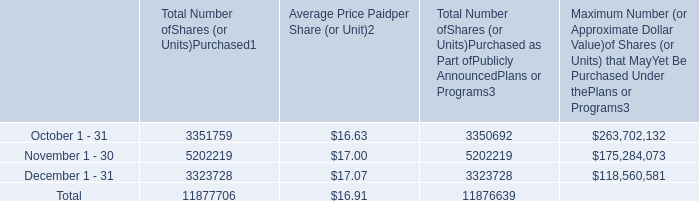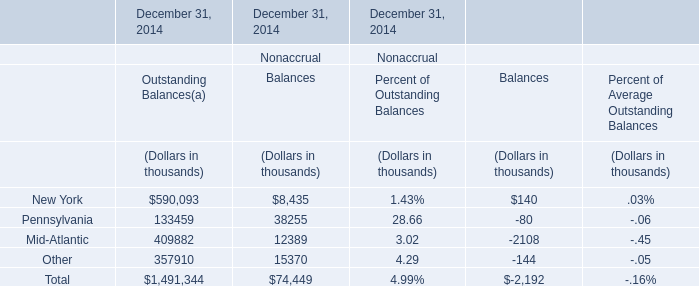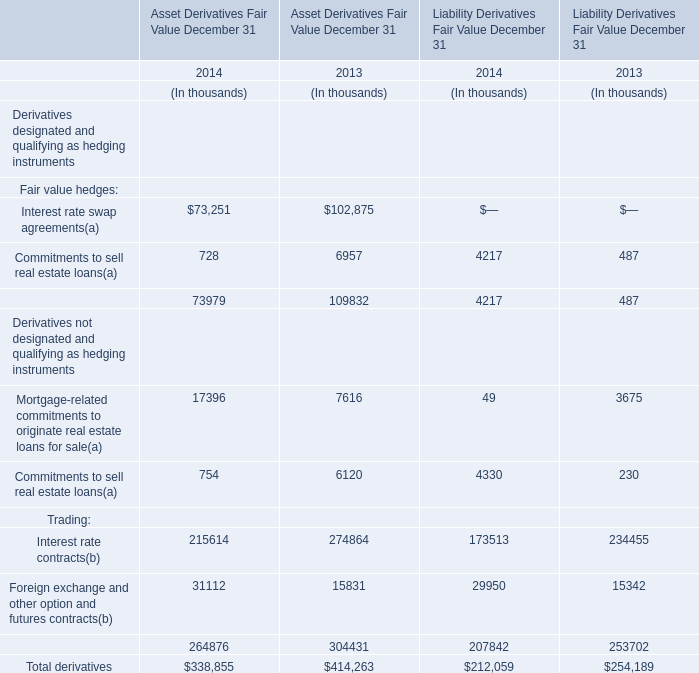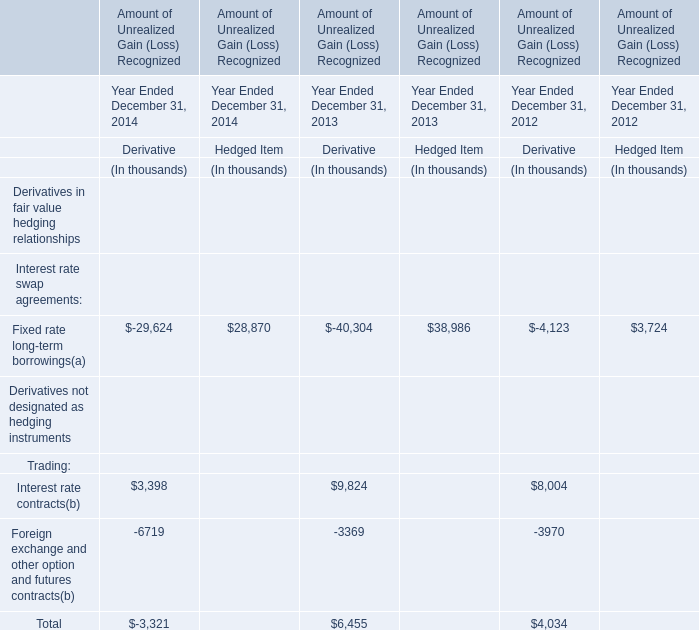What's the average of the Pennsylvania in the years where Total is negative? (in thousand) 
Computations: (((133459 + 38255) + 28.66) / 3)
Answer: 57247.55333. 